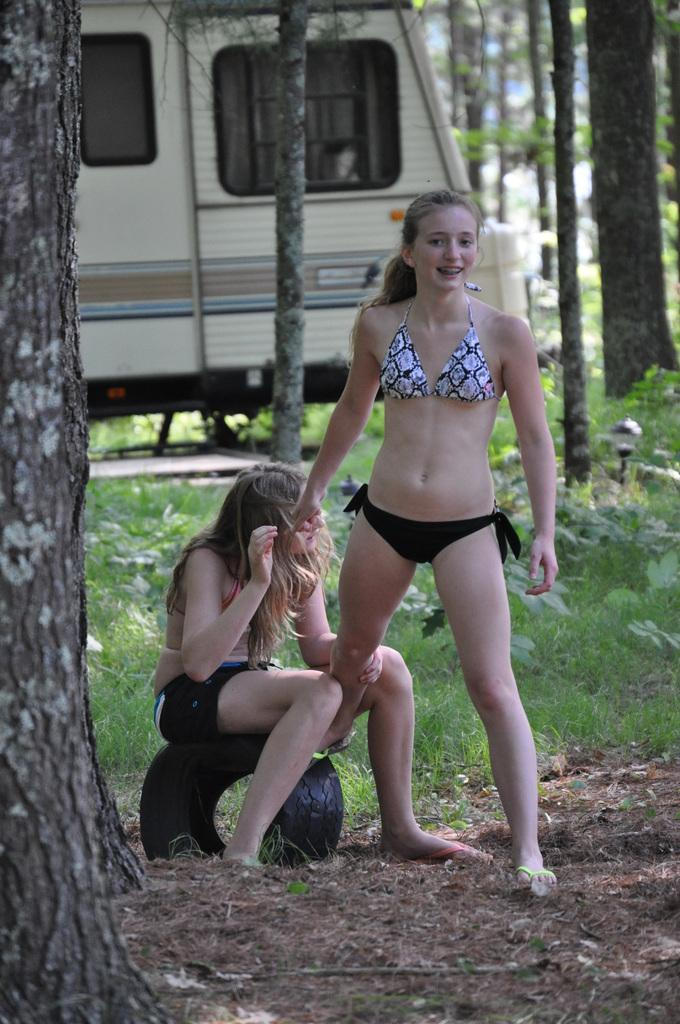How many people are in the image? There are two people in the image. What are the positions of the two people? One person is sitting on a tire, and the other person is standing. What type of surface is visible in the image? There is grass in the image. What else can be seen in the image besides the people and grass? There is a vehicle and trees in the image. What type of cherries are being picked by the fireman in the image? There is no fireman or cherries present in the image. 